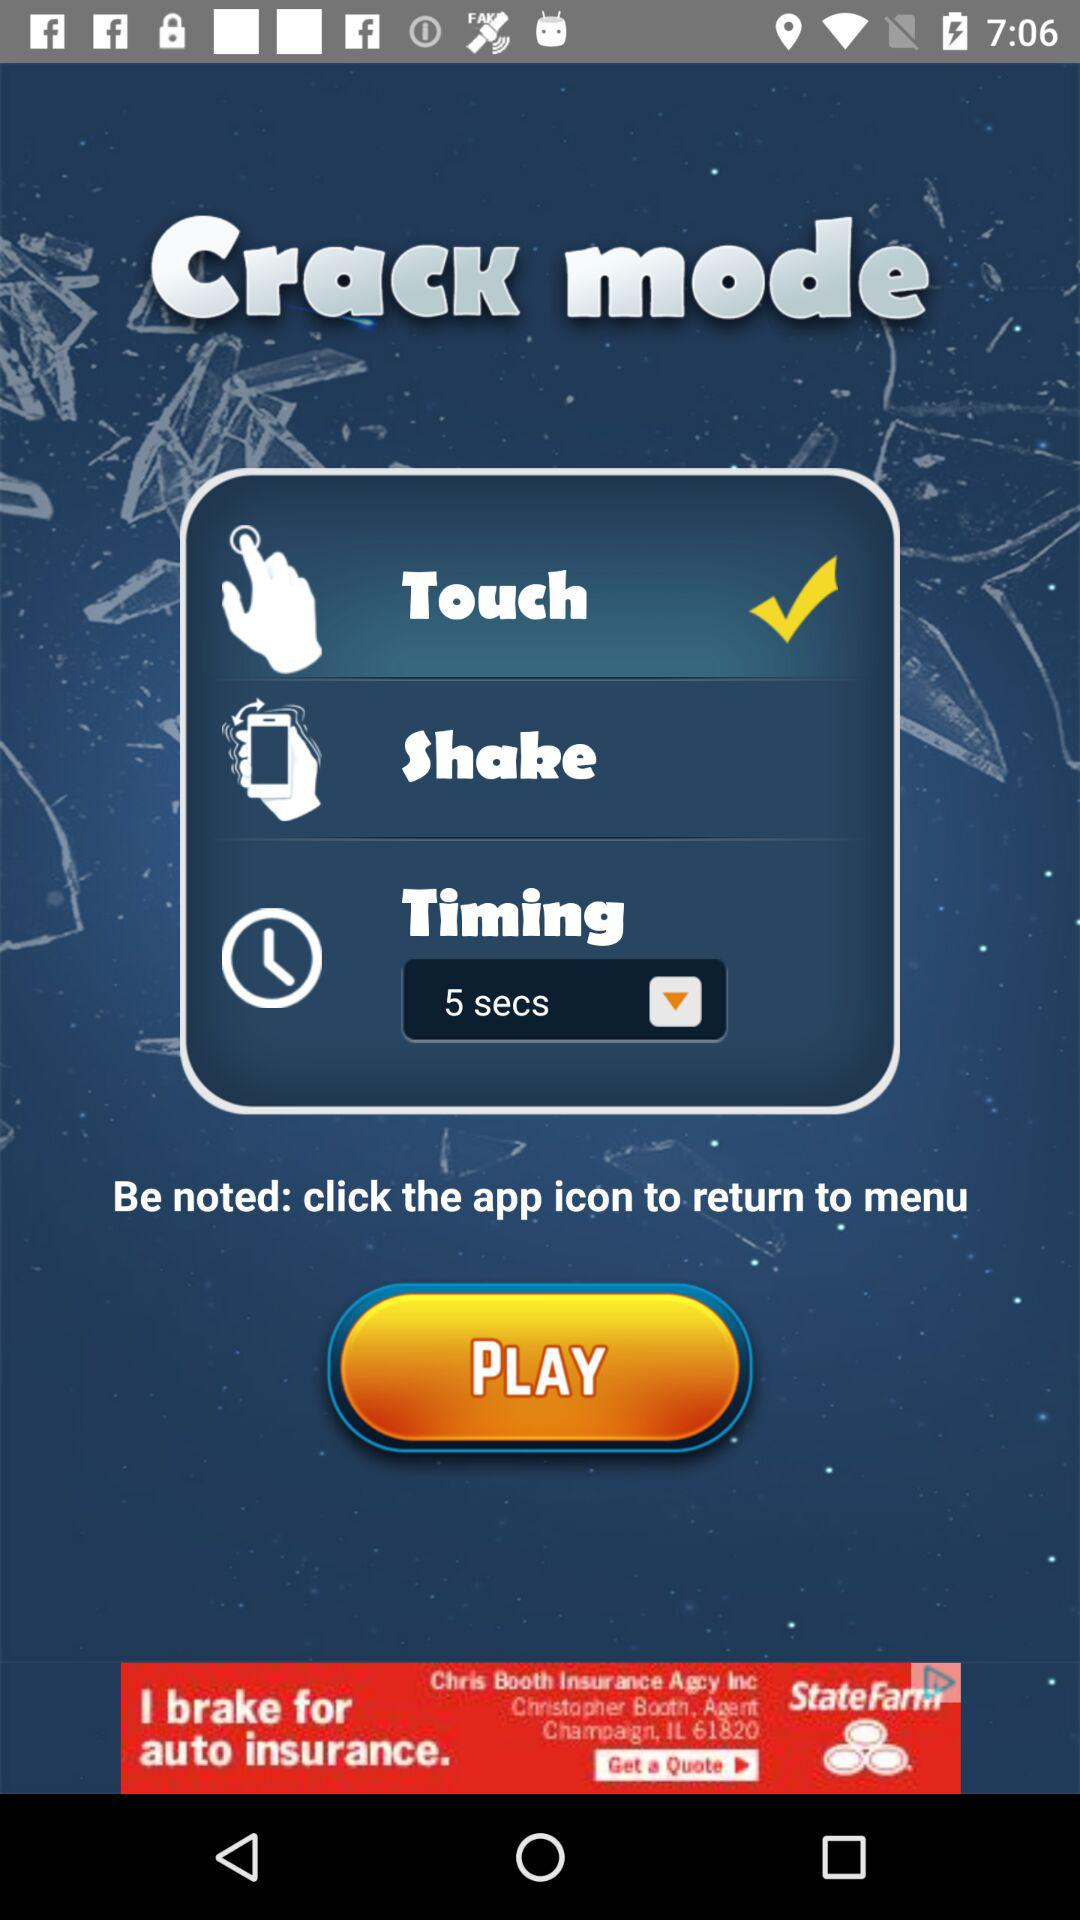What's the timing? The timing is 5 seconds. 